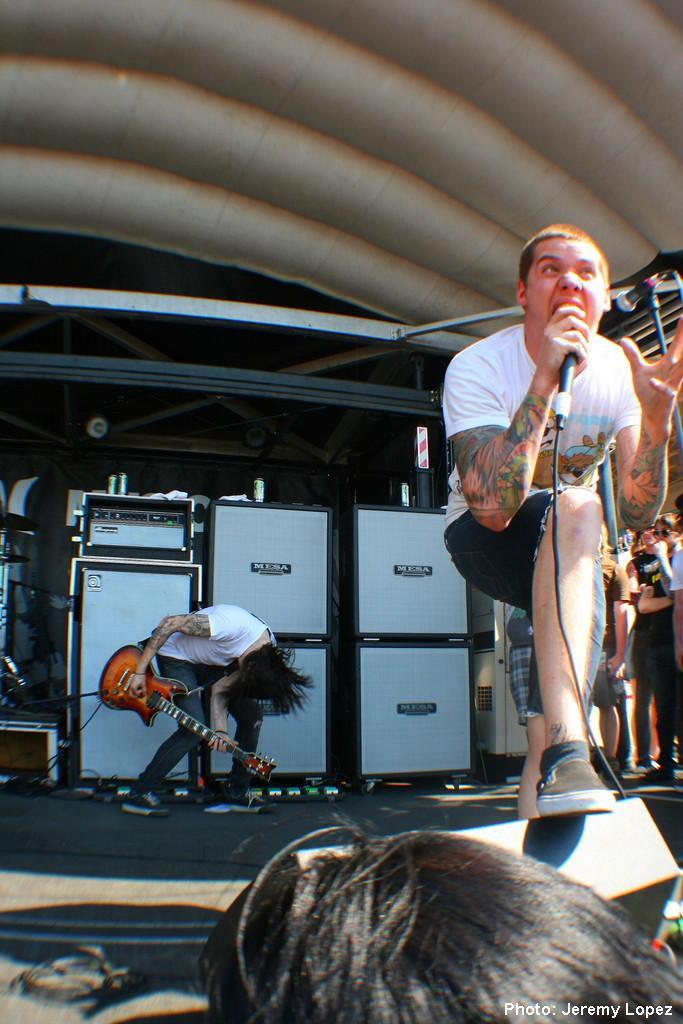Could you give a brief overview of what you see in this image? In this image there are some people are there on stage and some persons they are singing the song and playing the guitar behind the people there are so many instruments are there and background is very sunny. 